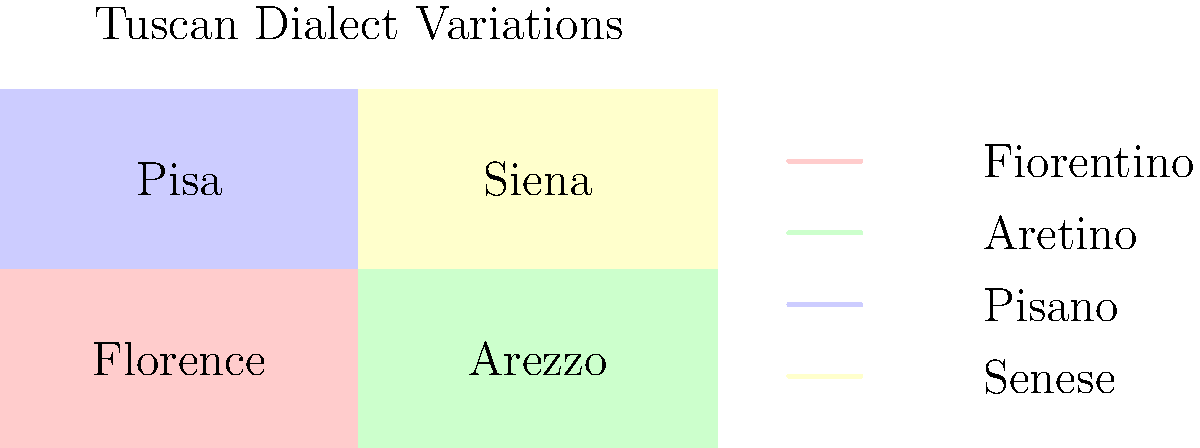Based on the color-coded map of Tuscany, which dialect variation is likely to have the strongest influence on the standard Italian language, and why? To answer this question, we need to consider the following steps:

1. Examine the map: The map shows four main dialect areas in Tuscany, each represented by a different color and associated with a major city.

2. Identify the dialect areas: 
   - Fiorentino (Florence): Red
   - Aretino (Arezzo): Green
   - Pisano (Pisa): Blue
   - Senese (Siena): Yellow

3. Consider historical context: Florence was the birthplace of the Italian Renaissance and home to many influential writers and poets, including Dante Alighieri, who wrote in the Florentine dialect.

4. Evaluate linguistic prestige: The Florentine dialect, due to its historical and cultural significance, gained prestige and became the basis for standard Italian.

5. Analyze geographical location: Florence is centrally located in Tuscany, which may have facilitated the spread of its dialect.

6. Consider literary and cultural influence: Many important works of Italian literature were written in the Florentine dialect, contributing to its widespread adoption.

Given these factors, the Fiorentino dialect, associated with Florence, is likely to have the strongest influence on standard Italian due to its historical prestige, cultural significance, and central location in Tuscany.
Answer: Fiorentino (Florence dialect) 